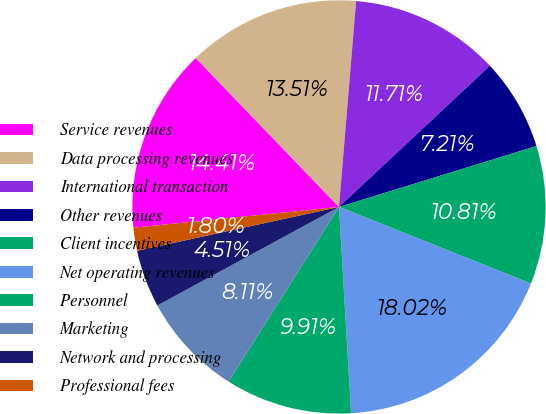Convert chart. <chart><loc_0><loc_0><loc_500><loc_500><pie_chart><fcel>Service revenues<fcel>Data processing revenues<fcel>International transaction<fcel>Other revenues<fcel>Client incentives<fcel>Net operating revenues<fcel>Personnel<fcel>Marketing<fcel>Network and processing<fcel>Professional fees<nl><fcel>14.41%<fcel>13.51%<fcel>11.71%<fcel>7.21%<fcel>10.81%<fcel>18.02%<fcel>9.91%<fcel>8.11%<fcel>4.51%<fcel>1.8%<nl></chart> 